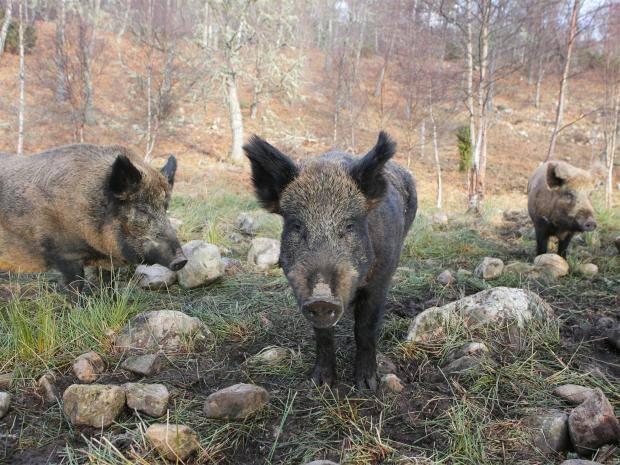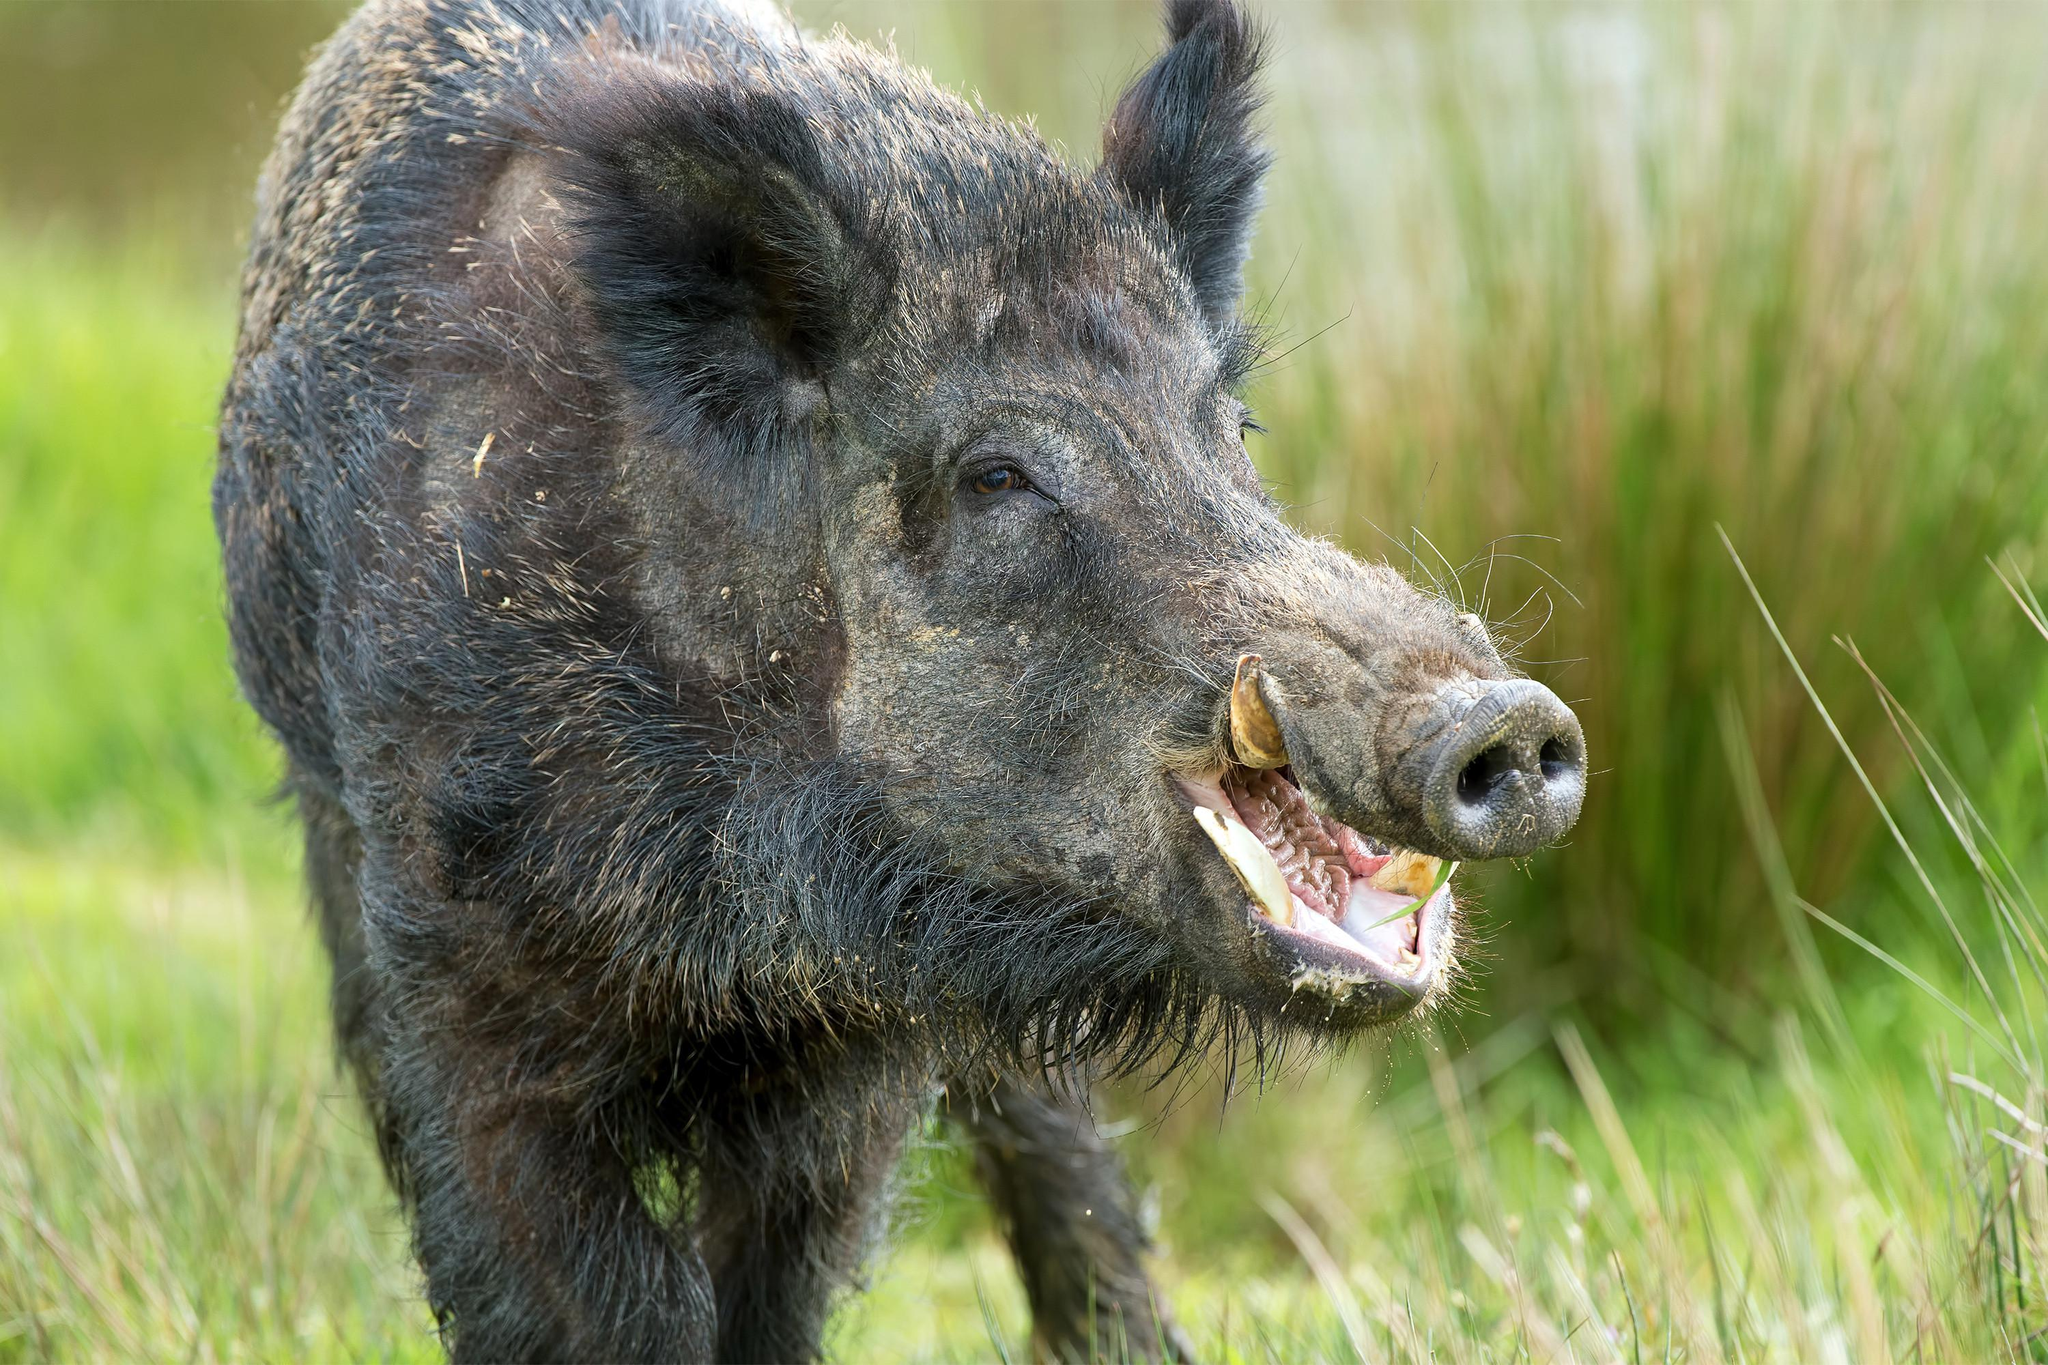The first image is the image on the left, the second image is the image on the right. Examine the images to the left and right. Is the description "There are at least two baby boars in the image on the right" accurate? Answer yes or no. No. The first image is the image on the left, the second image is the image on the right. Analyze the images presented: Is the assertion "Right image shows young and adult hogs." valid? Answer yes or no. No. 